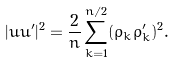<formula> <loc_0><loc_0><loc_500><loc_500>| u u ^ { \prime } | ^ { 2 } = \frac { 2 } { n } \sum _ { k = 1 } ^ { n / 2 } ( \rho _ { k } \rho _ { k } ^ { \prime } ) ^ { 2 } .</formula> 